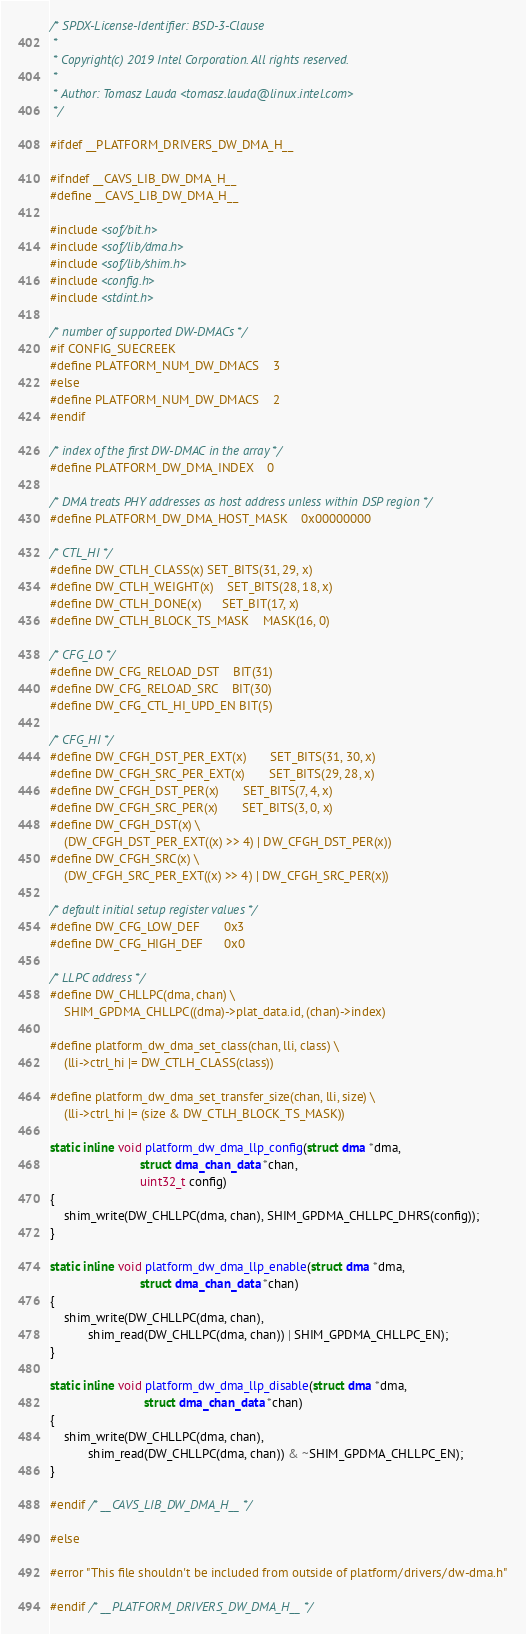<code> <loc_0><loc_0><loc_500><loc_500><_C_>/* SPDX-License-Identifier: BSD-3-Clause
 *
 * Copyright(c) 2019 Intel Corporation. All rights reserved.
 *
 * Author: Tomasz Lauda <tomasz.lauda@linux.intel.com>
 */

#ifdef __PLATFORM_DRIVERS_DW_DMA_H__

#ifndef __CAVS_LIB_DW_DMA_H__
#define __CAVS_LIB_DW_DMA_H__

#include <sof/bit.h>
#include <sof/lib/dma.h>
#include <sof/lib/shim.h>
#include <config.h>
#include <stdint.h>

/* number of supported DW-DMACs */
#if CONFIG_SUECREEK
#define PLATFORM_NUM_DW_DMACS	3
#else
#define PLATFORM_NUM_DW_DMACS	2
#endif

/* index of the first DW-DMAC in the array */
#define PLATFORM_DW_DMA_INDEX	0

/* DMA treats PHY addresses as host address unless within DSP region */
#define PLATFORM_DW_DMA_HOST_MASK	0x00000000

/* CTL_HI */
#define DW_CTLH_CLASS(x)	SET_BITS(31, 29, x)
#define DW_CTLH_WEIGHT(x)	SET_BITS(28, 18, x)
#define DW_CTLH_DONE(x)		SET_BIT(17, x)
#define DW_CTLH_BLOCK_TS_MASK	MASK(16, 0)

/* CFG_LO */
#define DW_CFG_RELOAD_DST	BIT(31)
#define DW_CFG_RELOAD_SRC	BIT(30)
#define DW_CFG_CTL_HI_UPD_EN	BIT(5)

/* CFG_HI */
#define DW_CFGH_DST_PER_EXT(x)		SET_BITS(31, 30, x)
#define DW_CFGH_SRC_PER_EXT(x)		SET_BITS(29, 28, x)
#define DW_CFGH_DST_PER(x)		SET_BITS(7, 4, x)
#define DW_CFGH_SRC_PER(x)		SET_BITS(3, 0, x)
#define DW_CFGH_DST(x) \
	(DW_CFGH_DST_PER_EXT((x) >> 4) | DW_CFGH_DST_PER(x))
#define DW_CFGH_SRC(x) \
	(DW_CFGH_SRC_PER_EXT((x) >> 4) | DW_CFGH_SRC_PER(x))

/* default initial setup register values */
#define DW_CFG_LOW_DEF		0x3
#define DW_CFG_HIGH_DEF		0x0

/* LLPC address */
#define DW_CHLLPC(dma, chan) \
	SHIM_GPDMA_CHLLPC((dma)->plat_data.id, (chan)->index)

#define platform_dw_dma_set_class(chan, lli, class) \
	(lli->ctrl_hi |= DW_CTLH_CLASS(class))

#define platform_dw_dma_set_transfer_size(chan, lli, size) \
	(lli->ctrl_hi |= (size & DW_CTLH_BLOCK_TS_MASK))

static inline void platform_dw_dma_llp_config(struct dma *dma,
					      struct dma_chan_data *chan,
					      uint32_t config)
{
	shim_write(DW_CHLLPC(dma, chan), SHIM_GPDMA_CHLLPC_DHRS(config));
}

static inline void platform_dw_dma_llp_enable(struct dma *dma,
					      struct dma_chan_data *chan)
{
	shim_write(DW_CHLLPC(dma, chan),
		   shim_read(DW_CHLLPC(dma, chan)) | SHIM_GPDMA_CHLLPC_EN);
}

static inline void platform_dw_dma_llp_disable(struct dma *dma,
					       struct dma_chan_data *chan)
{
	shim_write(DW_CHLLPC(dma, chan),
		   shim_read(DW_CHLLPC(dma, chan)) & ~SHIM_GPDMA_CHLLPC_EN);
}

#endif /* __CAVS_LIB_DW_DMA_H__ */

#else

#error "This file shouldn't be included from outside of platform/drivers/dw-dma.h"

#endif /* __PLATFORM_DRIVERS_DW_DMA_H__ */
</code> 